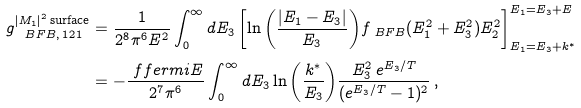Convert formula to latex. <formula><loc_0><loc_0><loc_500><loc_500>g _ { \ B F B , \, 1 2 1 } ^ { | M _ { 1 } | ^ { 2 } \, \text {surface} } & = \frac { 1 } { 2 ^ { 8 } \pi ^ { 6 } E ^ { 2 } } \int _ { 0 } ^ { \infty } d E _ { 3 } \left [ \ln { \left ( \frac { | E _ { 1 } - E _ { 3 } | } { E _ { 3 } } \right ) } f _ { \ B F B } ( E _ { 1 } ^ { 2 } + E _ { 3 } ^ { 2 } ) E _ { 2 } ^ { 2 } \right ] _ { E _ { 1 } = E _ { 3 } + k ^ { * } } ^ { E _ { 1 } = E _ { 3 } + E } \\ & = - \frac { \ f f e r m i { E } } { 2 ^ { 7 } \pi ^ { 6 } } \int _ { 0 } ^ { \infty } d E _ { 3 } \ln { \left ( \frac { k ^ { * } } { E _ { 3 } } \right ) } \frac { E _ { 3 } ^ { 2 } \, e ^ { E _ { 3 } / T } } { ( e ^ { E _ { 3 } / T } - 1 ) ^ { 2 } } \, ,</formula> 